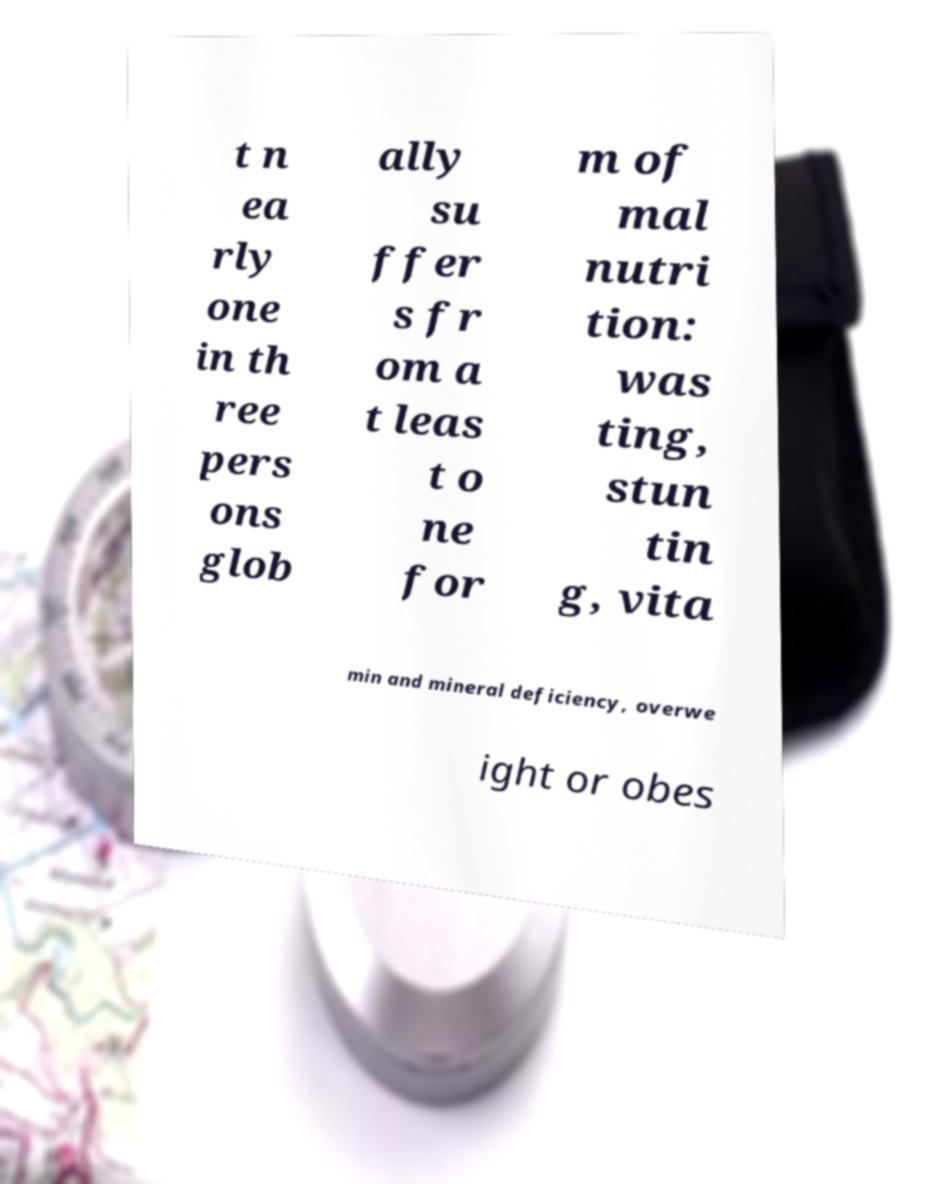What messages or text are displayed in this image? I need them in a readable, typed format. t n ea rly one in th ree pers ons glob ally su ffer s fr om a t leas t o ne for m of mal nutri tion: was ting, stun tin g, vita min and mineral deficiency, overwe ight or obes 